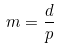<formula> <loc_0><loc_0><loc_500><loc_500>m = \frac { d } { p }</formula> 